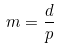<formula> <loc_0><loc_0><loc_500><loc_500>m = \frac { d } { p }</formula> 